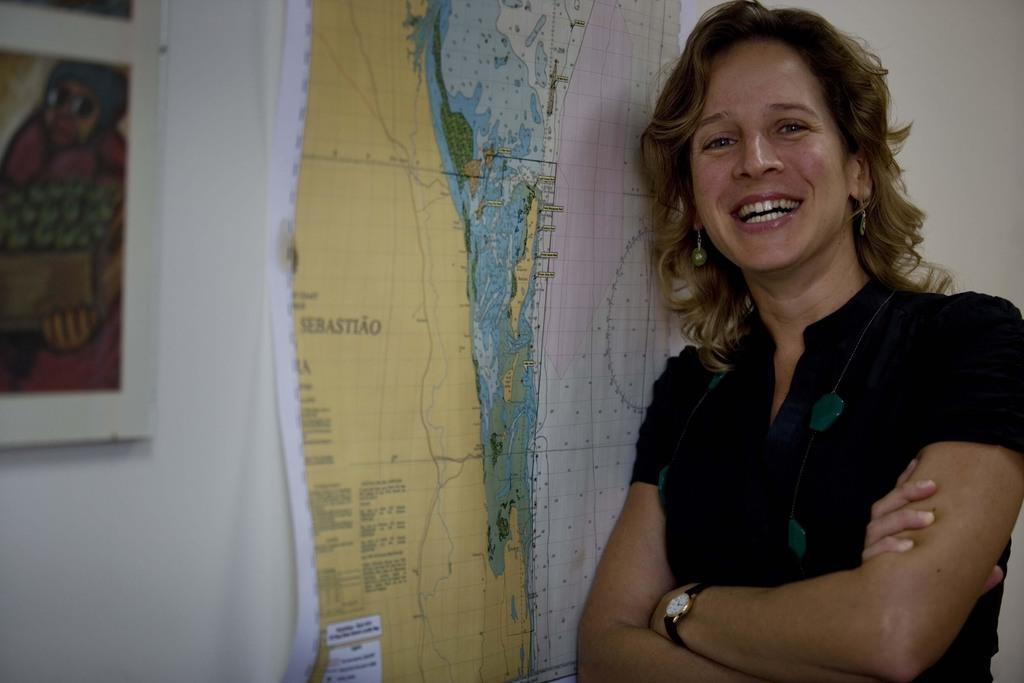Who is the main subject in the image? There is a woman in the image. What is the woman wearing? The woman is wearing a dress and a watch. What is the woman's posture in the image? The woman is standing. What can be seen in the background of the image? There is a map and a photo frame on the wall in the background of the image. Can you see a squirrel holding a balloon in the image? There is no squirrel or balloon present in the image. 